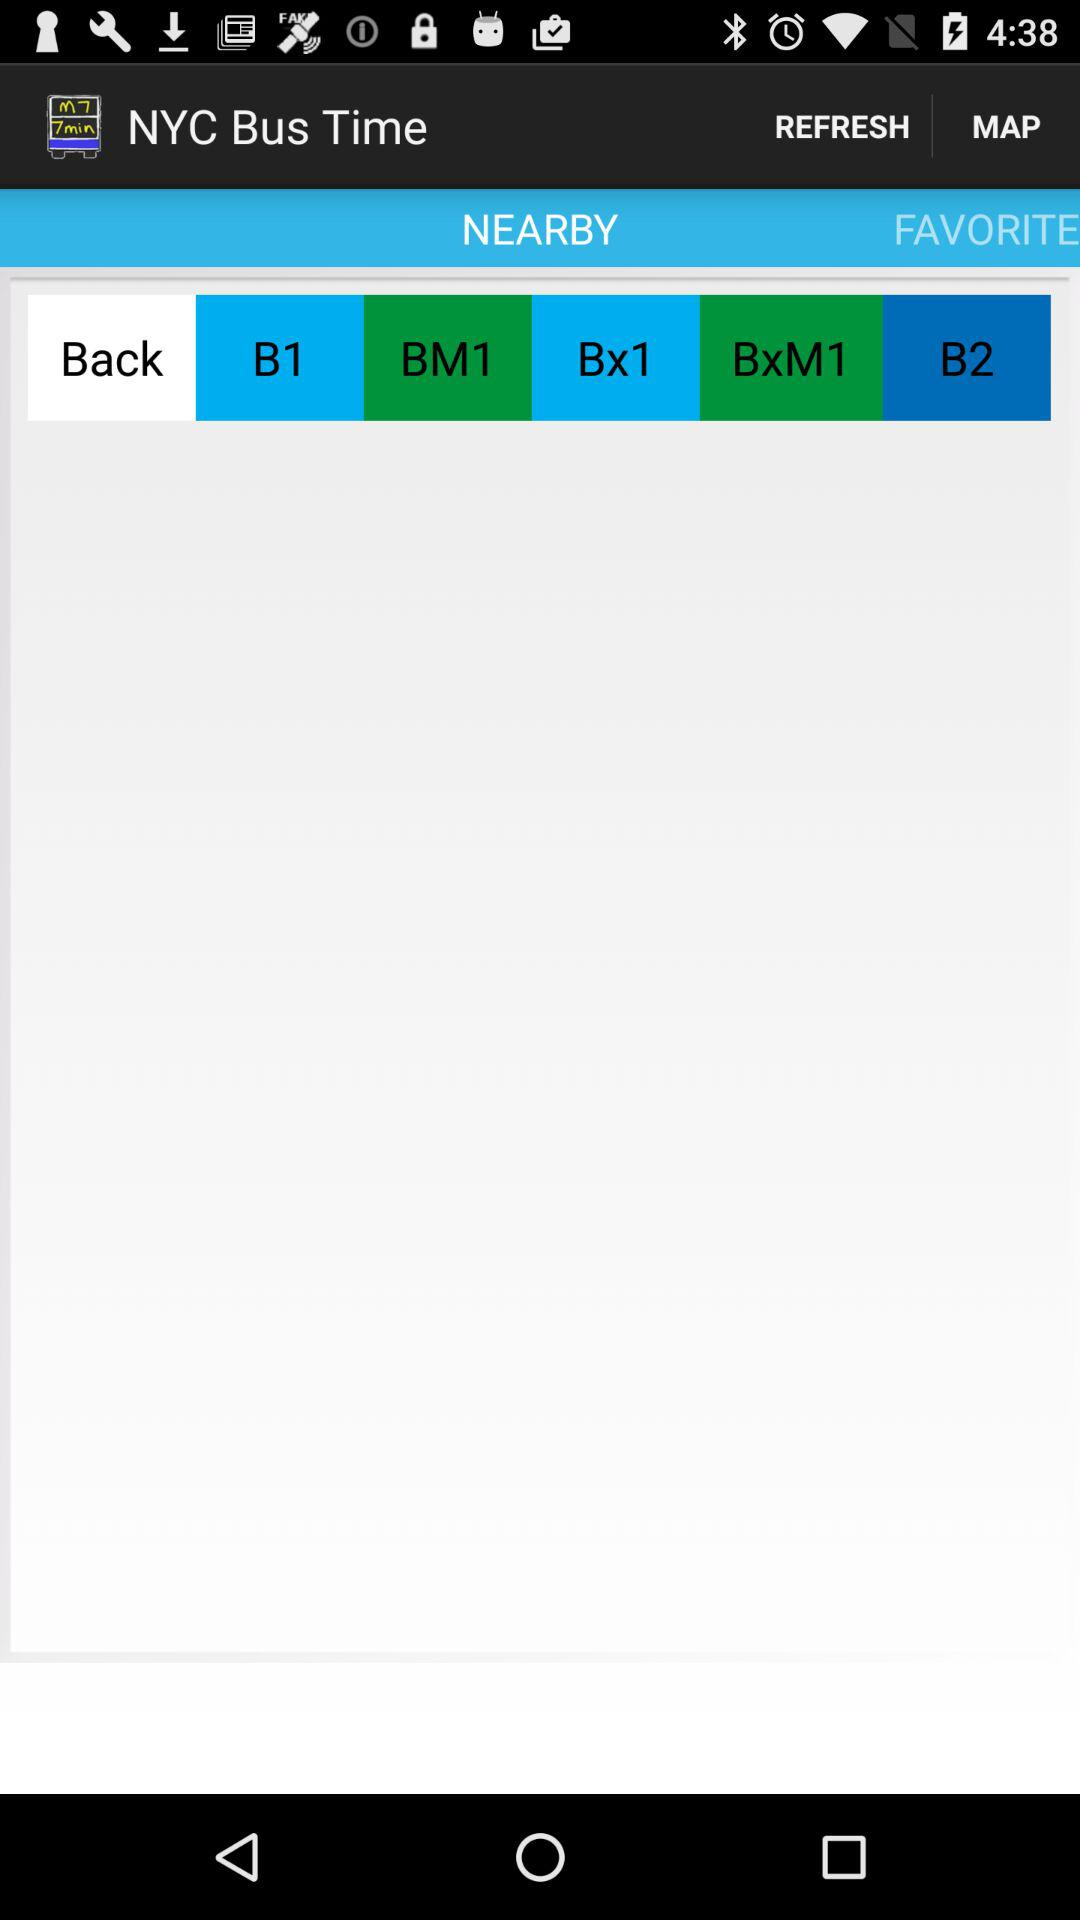What is the application name? The application name is "NYC Bus Time". 